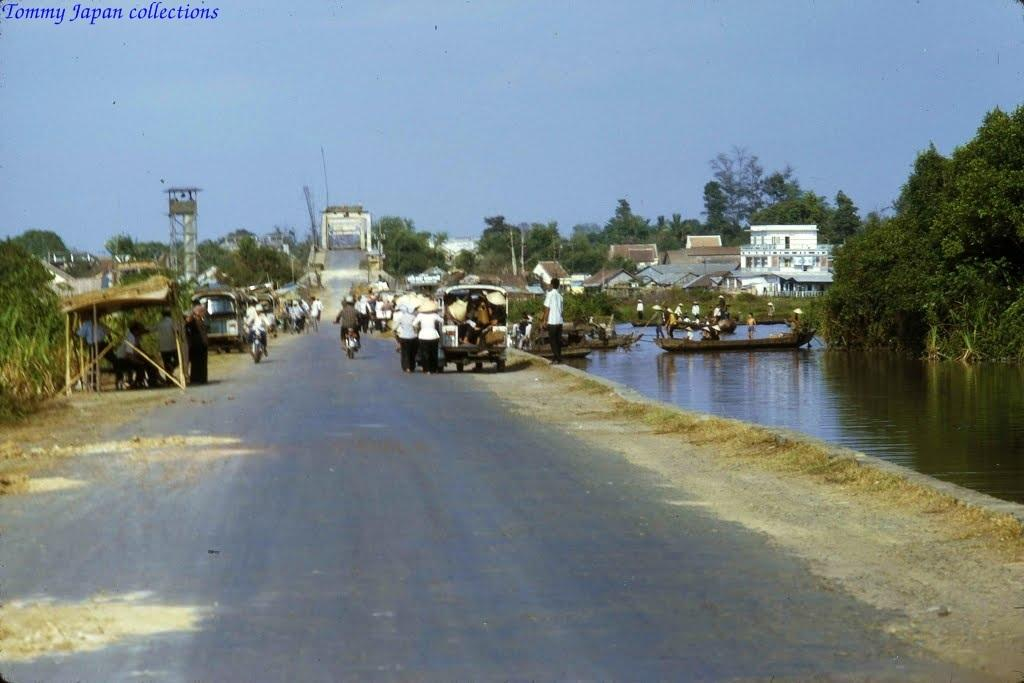What can be seen on the road in the image? There are vehicles and people on the road in the image. What is located at the left side of the image? There are trees at the left side of the image. What is present at the right side of the image? There is water at the right side of the image. What can be seen on the water in the image? There are boats on the water in the image. What else is visible in the image besides the road, trees, water, and boats? There are trees and buildings visible in the image. Can you see any wounds on the people in the image? There is no mention of any wounds or injuries in the image, so we cannot determine if any wounds are present. What type of feather can be seen in the image? There is no feather present in the image. 